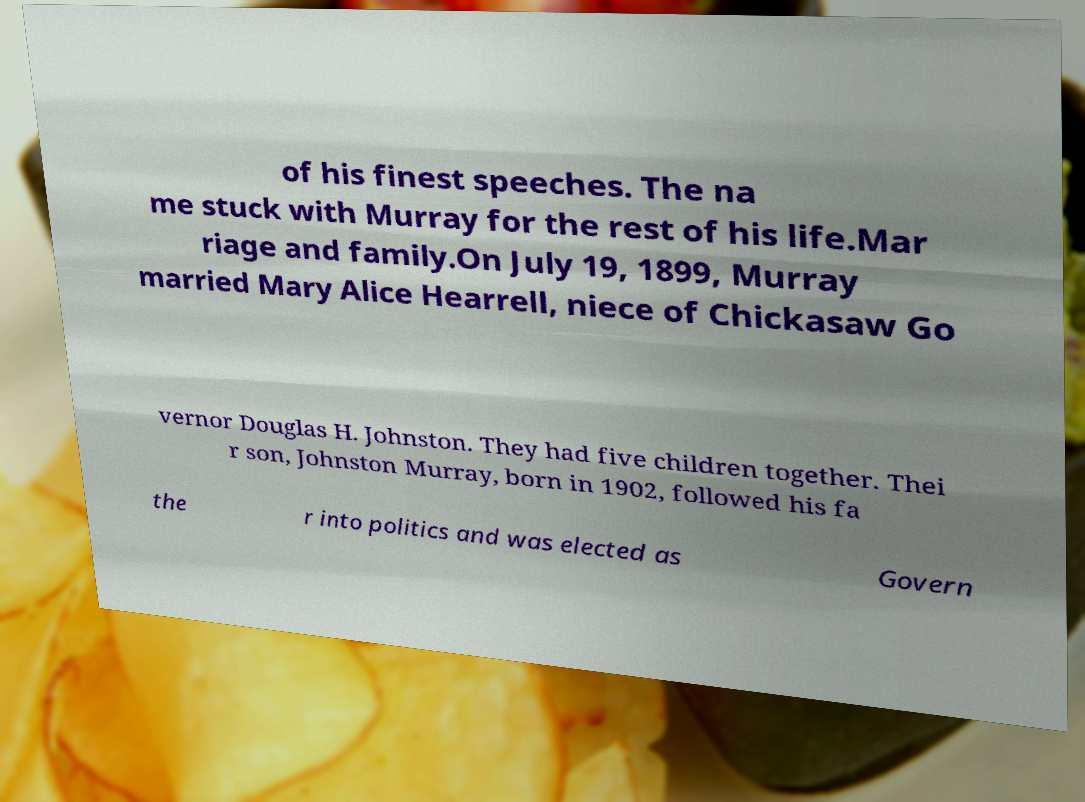I need the written content from this picture converted into text. Can you do that? of his finest speeches. The na me stuck with Murray for the rest of his life.Mar riage and family.On July 19, 1899, Murray married Mary Alice Hearrell, niece of Chickasaw Go vernor Douglas H. Johnston. They had five children together. Thei r son, Johnston Murray, born in 1902, followed his fa the r into politics and was elected as Govern 